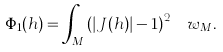<formula> <loc_0><loc_0><loc_500><loc_500>\Phi _ { 1 } ( h ) = \int _ { M } \left ( \left | J ( h ) \right | - 1 \right ) ^ { 2 } \, \ w _ { M } .</formula> 